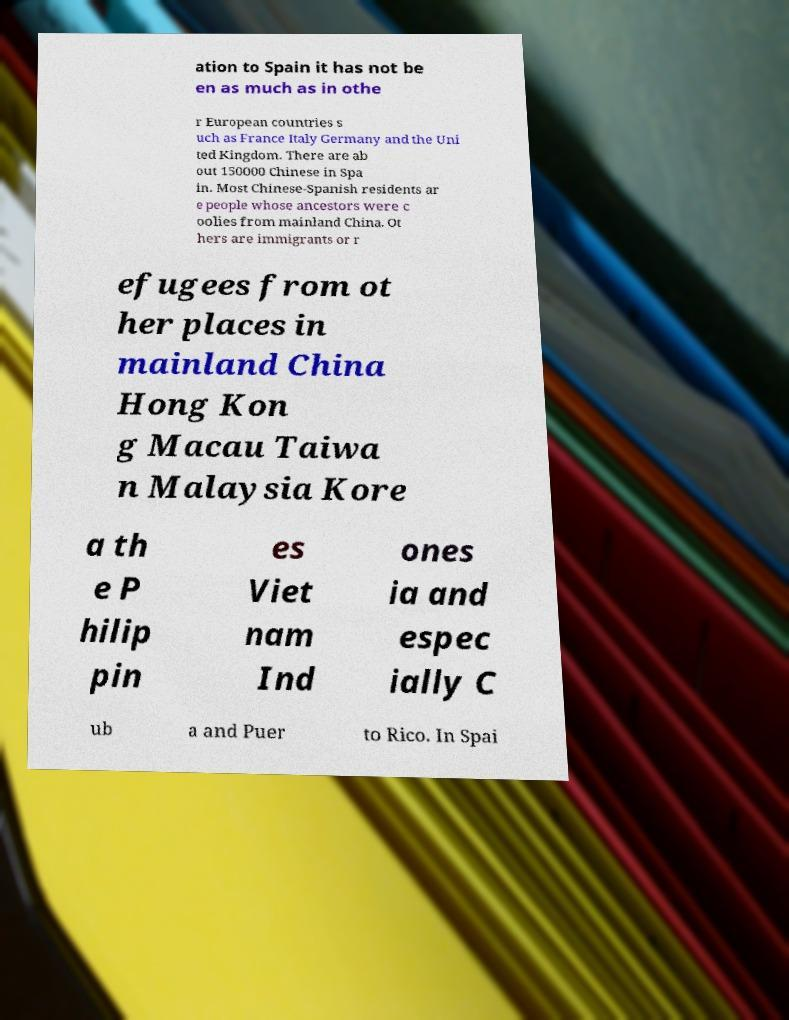Can you accurately transcribe the text from the provided image for me? ation to Spain it has not be en as much as in othe r European countries s uch as France Italy Germany and the Uni ted Kingdom. There are ab out 150000 Chinese in Spa in. Most Chinese-Spanish residents ar e people whose ancestors were c oolies from mainland China. Ot hers are immigrants or r efugees from ot her places in mainland China Hong Kon g Macau Taiwa n Malaysia Kore a th e P hilip pin es Viet nam Ind ones ia and espec ially C ub a and Puer to Rico. In Spai 